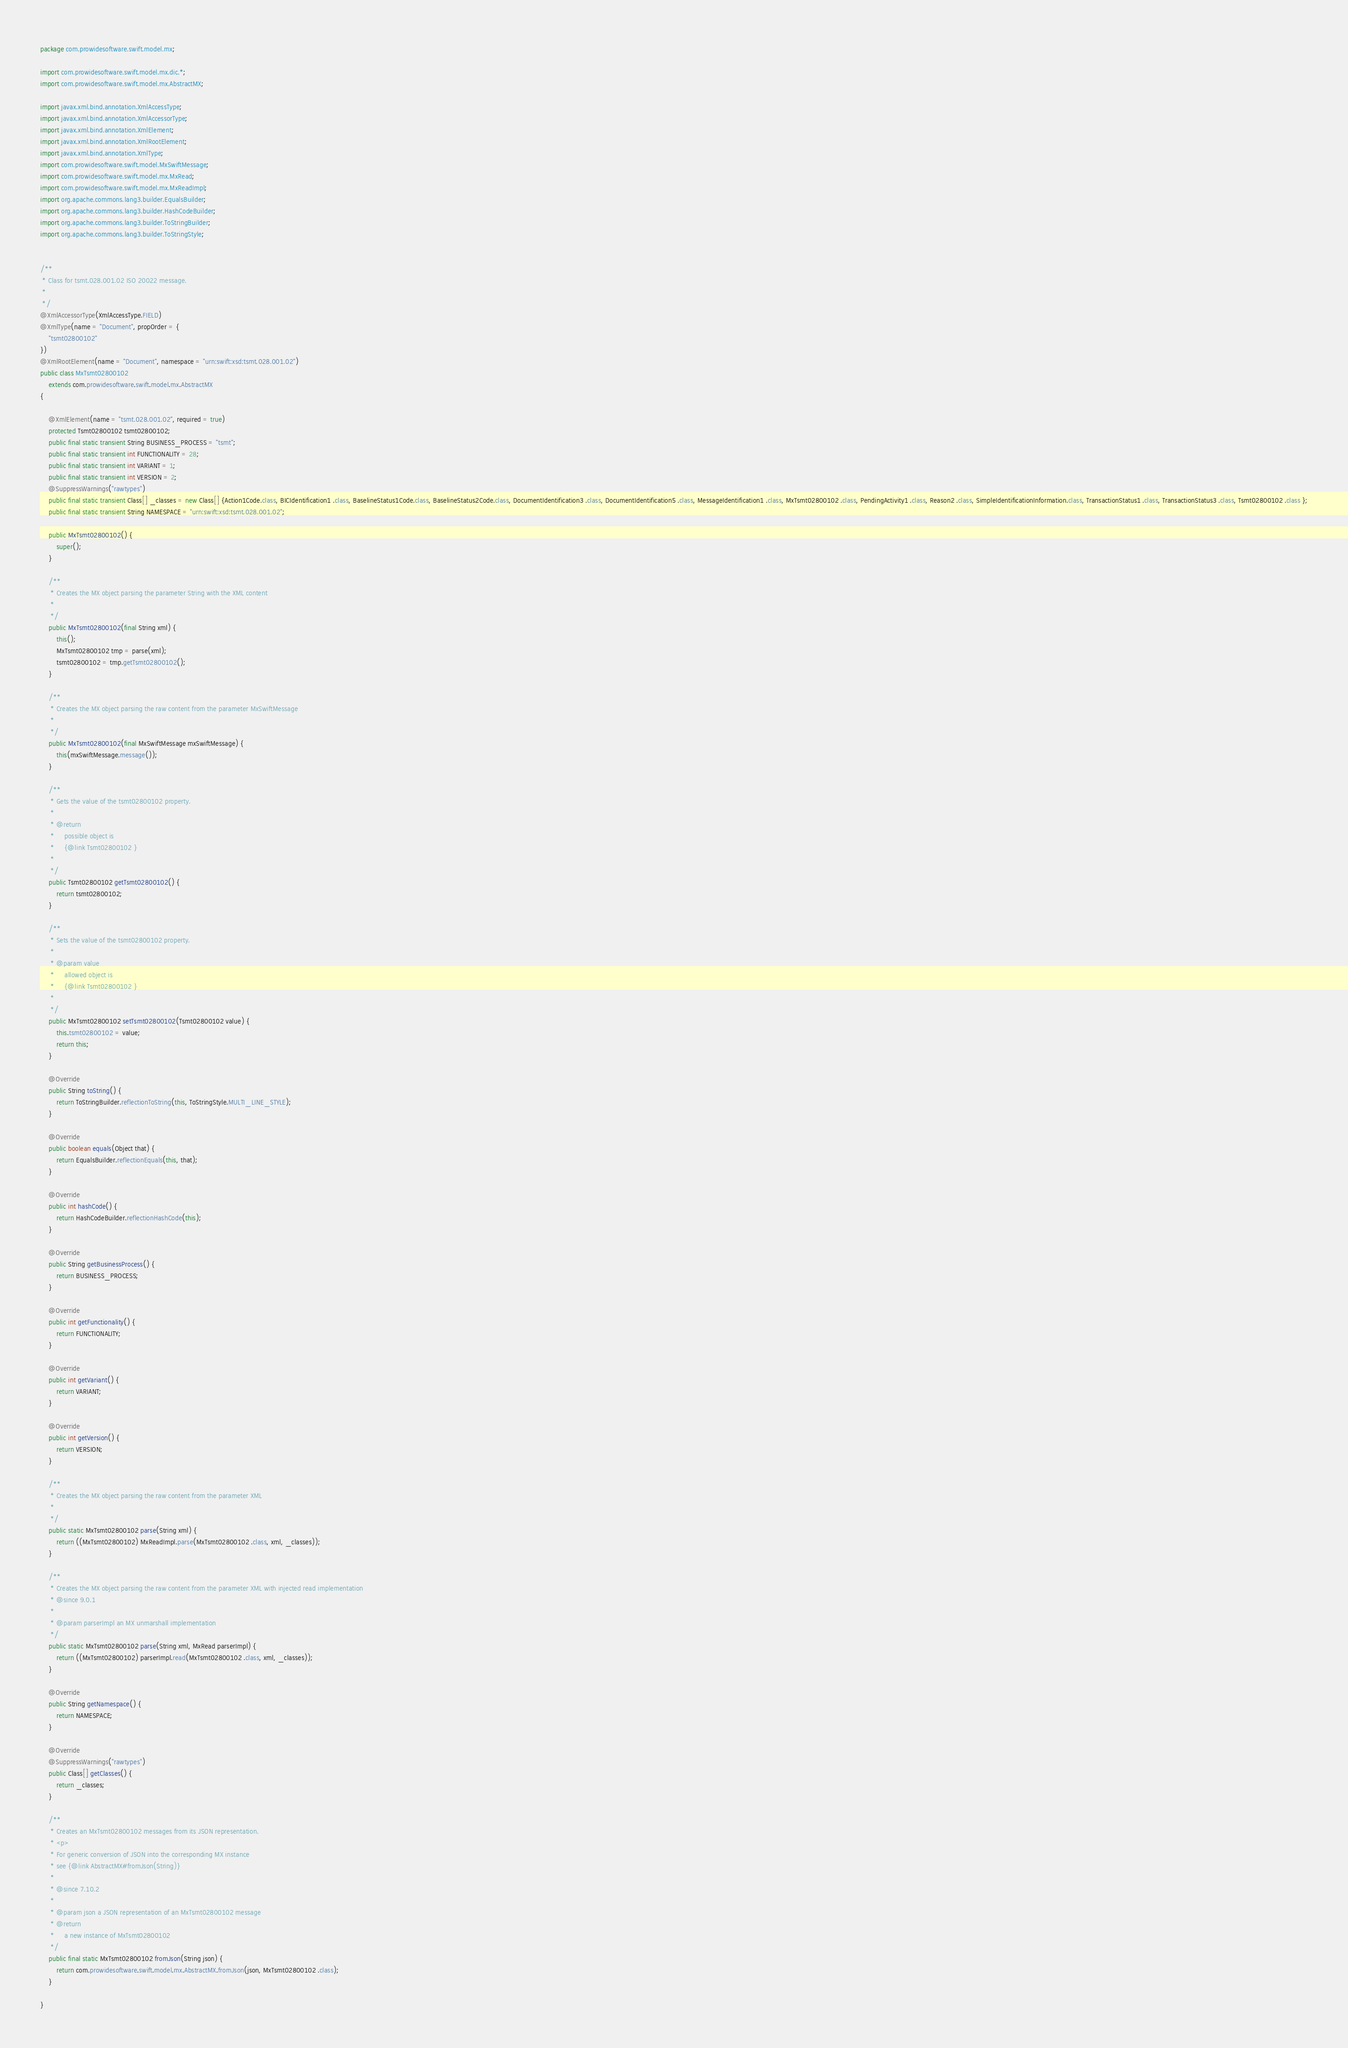<code> <loc_0><loc_0><loc_500><loc_500><_Java_>
package com.prowidesoftware.swift.model.mx;

import com.prowidesoftware.swift.model.mx.dic.*;
import com.prowidesoftware.swift.model.mx.AbstractMX;

import javax.xml.bind.annotation.XmlAccessType;
import javax.xml.bind.annotation.XmlAccessorType;
import javax.xml.bind.annotation.XmlElement;
import javax.xml.bind.annotation.XmlRootElement;
import javax.xml.bind.annotation.XmlType;
import com.prowidesoftware.swift.model.MxSwiftMessage;
import com.prowidesoftware.swift.model.mx.MxRead;
import com.prowidesoftware.swift.model.mx.MxReadImpl;
import org.apache.commons.lang3.builder.EqualsBuilder;
import org.apache.commons.lang3.builder.HashCodeBuilder;
import org.apache.commons.lang3.builder.ToStringBuilder;
import org.apache.commons.lang3.builder.ToStringStyle;


/**
 * Class for tsmt.028.001.02 ISO 20022 message.
 * 
 */
@XmlAccessorType(XmlAccessType.FIELD)
@XmlType(name = "Document", propOrder = {
    "tsmt02800102"
})
@XmlRootElement(name = "Document", namespace = "urn:swift:xsd:tsmt.028.001.02")
public class MxTsmt02800102
    extends com.prowidesoftware.swift.model.mx.AbstractMX
{

    @XmlElement(name = "tsmt.028.001.02", required = true)
    protected Tsmt02800102 tsmt02800102;
    public final static transient String BUSINESS_PROCESS = "tsmt";
    public final static transient int FUNCTIONALITY = 28;
    public final static transient int VARIANT = 1;
    public final static transient int VERSION = 2;
    @SuppressWarnings("rawtypes")
    public final static transient Class[] _classes = new Class[] {Action1Code.class, BICIdentification1 .class, BaselineStatus1Code.class, BaselineStatus2Code.class, DocumentIdentification3 .class, DocumentIdentification5 .class, MessageIdentification1 .class, MxTsmt02800102 .class, PendingActivity1 .class, Reason2 .class, SimpleIdentificationInformation.class, TransactionStatus1 .class, TransactionStatus3 .class, Tsmt02800102 .class };
    public final static transient String NAMESPACE = "urn:swift:xsd:tsmt.028.001.02";

    public MxTsmt02800102() {
        super();
    }

    /**
     * Creates the MX object parsing the parameter String with the XML content
     * 
     */
    public MxTsmt02800102(final String xml) {
        this();
        MxTsmt02800102 tmp = parse(xml);
        tsmt02800102 = tmp.getTsmt02800102();
    }

    /**
     * Creates the MX object parsing the raw content from the parameter MxSwiftMessage
     * 
     */
    public MxTsmt02800102(final MxSwiftMessage mxSwiftMessage) {
        this(mxSwiftMessage.message());
    }

    /**
     * Gets the value of the tsmt02800102 property.
     * 
     * @return
     *     possible object is
     *     {@link Tsmt02800102 }
     *     
     */
    public Tsmt02800102 getTsmt02800102() {
        return tsmt02800102;
    }

    /**
     * Sets the value of the tsmt02800102 property.
     * 
     * @param value
     *     allowed object is
     *     {@link Tsmt02800102 }
     *     
     */
    public MxTsmt02800102 setTsmt02800102(Tsmt02800102 value) {
        this.tsmt02800102 = value;
        return this;
    }

    @Override
    public String toString() {
        return ToStringBuilder.reflectionToString(this, ToStringStyle.MULTI_LINE_STYLE);
    }

    @Override
    public boolean equals(Object that) {
        return EqualsBuilder.reflectionEquals(this, that);
    }

    @Override
    public int hashCode() {
        return HashCodeBuilder.reflectionHashCode(this);
    }

    @Override
    public String getBusinessProcess() {
        return BUSINESS_PROCESS;
    }

    @Override
    public int getFunctionality() {
        return FUNCTIONALITY;
    }

    @Override
    public int getVariant() {
        return VARIANT;
    }

    @Override
    public int getVersion() {
        return VERSION;
    }

    /**
     * Creates the MX object parsing the raw content from the parameter XML
     * 
     */
    public static MxTsmt02800102 parse(String xml) {
        return ((MxTsmt02800102) MxReadImpl.parse(MxTsmt02800102 .class, xml, _classes));
    }

    /**
     * Creates the MX object parsing the raw content from the parameter XML with injected read implementation
     * @since 9.0.1
     * 
     * @param parserImpl an MX unmarshall implementation
     */
    public static MxTsmt02800102 parse(String xml, MxRead parserImpl) {
        return ((MxTsmt02800102) parserImpl.read(MxTsmt02800102 .class, xml, _classes));
    }

    @Override
    public String getNamespace() {
        return NAMESPACE;
    }

    @Override
    @SuppressWarnings("rawtypes")
    public Class[] getClasses() {
        return _classes;
    }

    /**
     * Creates an MxTsmt02800102 messages from its JSON representation.
     * <p>
     * For generic conversion of JSON into the corresponding MX instance 
     * see {@link AbstractMX#fromJson(String)}
     * 
     * @since 7.10.2
     * 
     * @param json a JSON representation of an MxTsmt02800102 message
     * @return
     *     a new instance of MxTsmt02800102
     */
    public final static MxTsmt02800102 fromJson(String json) {
        return com.prowidesoftware.swift.model.mx.AbstractMX.fromJson(json, MxTsmt02800102 .class);
    }

}
</code> 